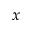<formula> <loc_0><loc_0><loc_500><loc_500>x</formula> 